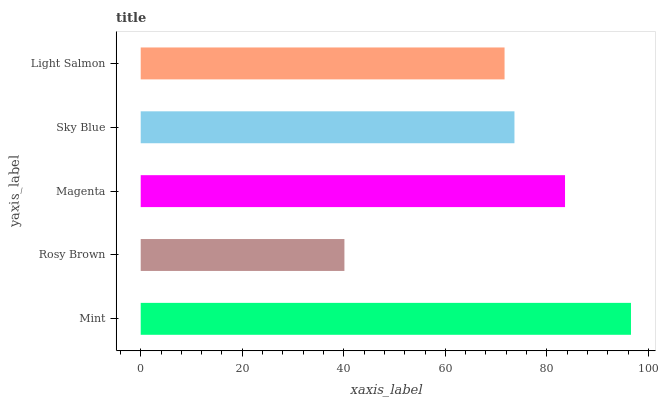Is Rosy Brown the minimum?
Answer yes or no. Yes. Is Mint the maximum?
Answer yes or no. Yes. Is Magenta the minimum?
Answer yes or no. No. Is Magenta the maximum?
Answer yes or no. No. Is Magenta greater than Rosy Brown?
Answer yes or no. Yes. Is Rosy Brown less than Magenta?
Answer yes or no. Yes. Is Rosy Brown greater than Magenta?
Answer yes or no. No. Is Magenta less than Rosy Brown?
Answer yes or no. No. Is Sky Blue the high median?
Answer yes or no. Yes. Is Sky Blue the low median?
Answer yes or no. Yes. Is Light Salmon the high median?
Answer yes or no. No. Is Mint the low median?
Answer yes or no. No. 